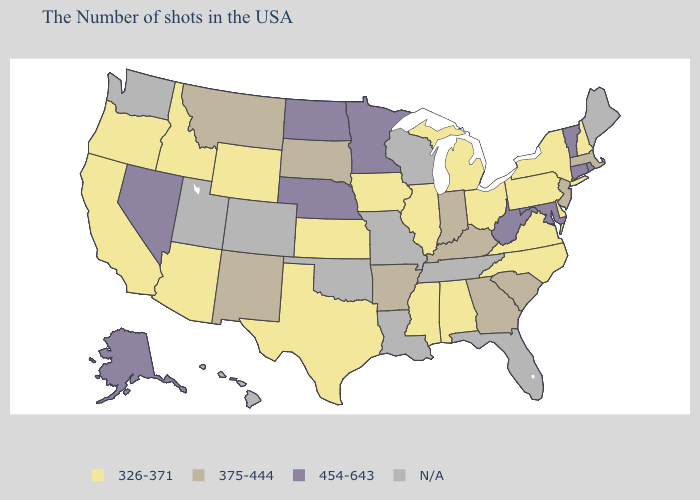Among the states that border Georgia , does Alabama have the highest value?
Be succinct. No. Name the states that have a value in the range 454-643?
Short answer required. Rhode Island, Vermont, Connecticut, Maryland, West Virginia, Minnesota, Nebraska, North Dakota, Nevada, Alaska. What is the value of Arkansas?
Write a very short answer. 375-444. Which states hav the highest value in the South?
Answer briefly. Maryland, West Virginia. Does West Virginia have the highest value in the USA?
Short answer required. Yes. What is the lowest value in the MidWest?
Concise answer only. 326-371. What is the value of Kentucky?
Short answer required. 375-444. Which states have the lowest value in the USA?
Short answer required. New Hampshire, New York, Delaware, Pennsylvania, Virginia, North Carolina, Ohio, Michigan, Alabama, Illinois, Mississippi, Iowa, Kansas, Texas, Wyoming, Arizona, Idaho, California, Oregon. What is the value of Hawaii?
Short answer required. N/A. Does Minnesota have the lowest value in the USA?
Be succinct. No. Which states have the lowest value in the USA?
Be succinct. New Hampshire, New York, Delaware, Pennsylvania, Virginia, North Carolina, Ohio, Michigan, Alabama, Illinois, Mississippi, Iowa, Kansas, Texas, Wyoming, Arizona, Idaho, California, Oregon. How many symbols are there in the legend?
Write a very short answer. 4. Name the states that have a value in the range N/A?
Quick response, please. Maine, Florida, Tennessee, Wisconsin, Louisiana, Missouri, Oklahoma, Colorado, Utah, Washington, Hawaii. Does Arizona have the lowest value in the USA?
Answer briefly. Yes. Among the states that border Iowa , does Illinois have the lowest value?
Answer briefly. Yes. 